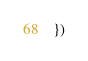<code> <loc_0><loc_0><loc_500><loc_500><_TypeScript_>})
</code> 